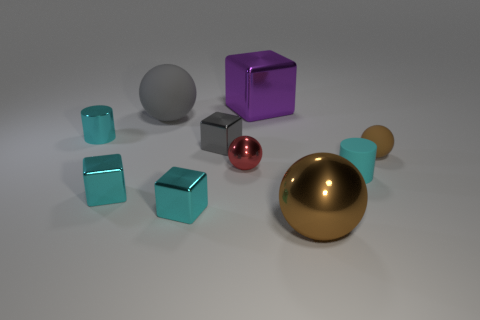Can you tell me about the sizes and colors of the objects in this image? Certainly! This image features objects of various sizes and colors. There are two larger spheres, a shiny gold one and a matte gray one; a smaller, glossy red sphere; and a range of cubes. These cubes are in three sizes: small, medium, and one large. The small and medium cubes are a cyan-like color, while the large cube has a reflective purple surface. Additionally, there's a brown capsule-shaped object with a dull surface. 